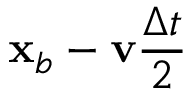Convert formula to latex. <formula><loc_0><loc_0><loc_500><loc_500>\mathbf x _ { b } - \mathbf v \frac { \Delta t } { 2 }</formula> 